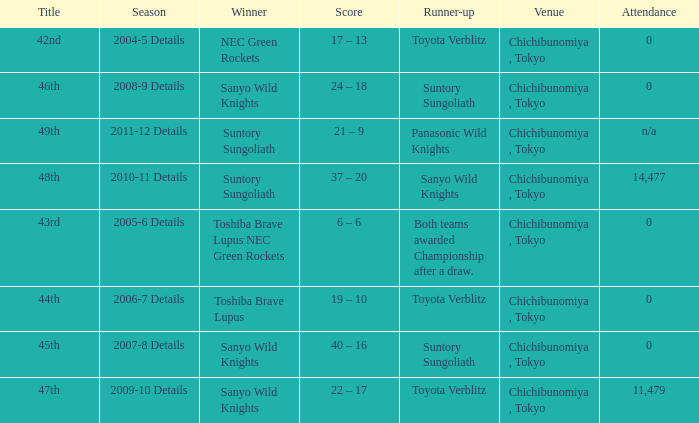What is the Score when the winner was suntory sungoliath, and the number attendance was n/a? 21 – 9. 